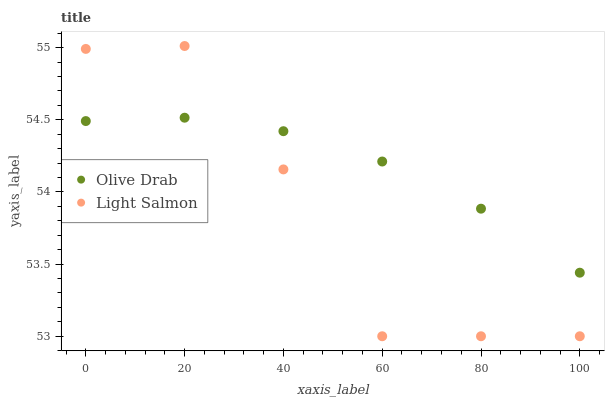Does Light Salmon have the minimum area under the curve?
Answer yes or no. Yes. Does Olive Drab have the maximum area under the curve?
Answer yes or no. Yes. Does Olive Drab have the minimum area under the curve?
Answer yes or no. No. Is Olive Drab the smoothest?
Answer yes or no. Yes. Is Light Salmon the roughest?
Answer yes or no. Yes. Is Olive Drab the roughest?
Answer yes or no. No. Does Light Salmon have the lowest value?
Answer yes or no. Yes. Does Olive Drab have the lowest value?
Answer yes or no. No. Does Light Salmon have the highest value?
Answer yes or no. Yes. Does Olive Drab have the highest value?
Answer yes or no. No. Does Light Salmon intersect Olive Drab?
Answer yes or no. Yes. Is Light Salmon less than Olive Drab?
Answer yes or no. No. Is Light Salmon greater than Olive Drab?
Answer yes or no. No. 